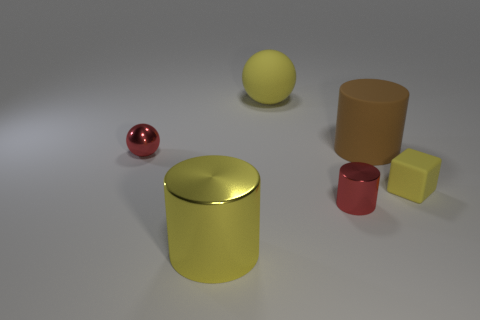Subtract all red cylinders. Subtract all yellow blocks. How many cylinders are left? 2 Add 4 large yellow matte spheres. How many objects exist? 10 Subtract all spheres. How many objects are left? 4 Add 6 tiny brown metal cylinders. How many tiny brown metal cylinders exist? 6 Subtract 0 green balls. How many objects are left? 6 Subtract all tiny red matte spheres. Subtract all yellow metal cylinders. How many objects are left? 5 Add 4 big matte cylinders. How many big matte cylinders are left? 5 